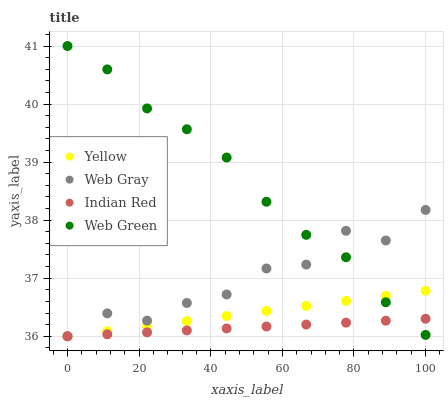Does Indian Red have the minimum area under the curve?
Answer yes or no. Yes. Does Web Green have the maximum area under the curve?
Answer yes or no. Yes. Does Web Gray have the minimum area under the curve?
Answer yes or no. No. Does Web Gray have the maximum area under the curve?
Answer yes or no. No. Is Yellow the smoothest?
Answer yes or no. Yes. Is Web Gray the roughest?
Answer yes or no. Yes. Is Indian Red the smoothest?
Answer yes or no. No. Is Indian Red the roughest?
Answer yes or no. No. Does Web Gray have the lowest value?
Answer yes or no. Yes. Does Web Green have the highest value?
Answer yes or no. Yes. Does Web Gray have the highest value?
Answer yes or no. No. Does Indian Red intersect Web Gray?
Answer yes or no. Yes. Is Indian Red less than Web Gray?
Answer yes or no. No. Is Indian Red greater than Web Gray?
Answer yes or no. No. 